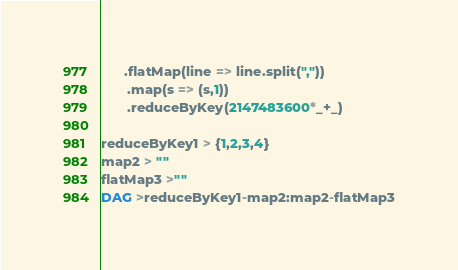<code> <loc_0><loc_0><loc_500><loc_500><_Scala_>      .flatMap(line => line.split(","))
       .map(s => (s,1))
       .reduceByKey(2147483600*_+_)

reduceByKey1 > {1,2,3,4}
map2 > ""
flatMap3 >""
DAG >reduceByKey1-map2:map2-flatMap3
</code> 